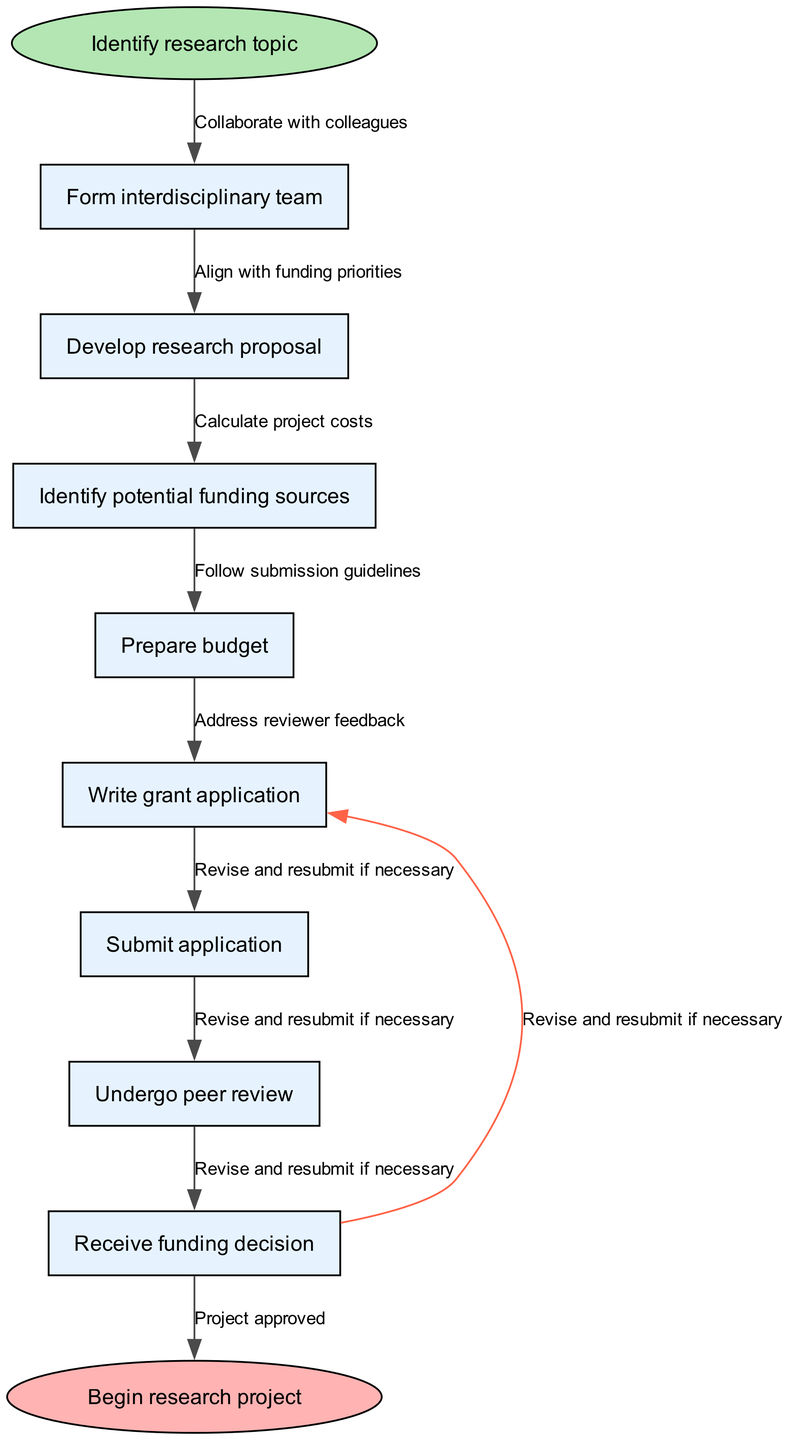What is the starting point of the process? The diagram indicates that the process starts with "Identify research topic". This is the first node connected to the starting point indicated by the ellipse shape.
Answer: Identify research topic How many nodes are in the diagram? By counting the nodes listed in the diagram, we determine that there are a total of eight nodes, which include both the start and end nodes along with the intermediate steps.
Answer: 8 What is the final step before beginning the research project? The diagram shows that the last step before starting the research project is receiving the funding decision, which is the second to last node.
Answer: Receive funding decision Which node follows "Develop research proposal"? By looking at the sequence of nodes, we see that after "Develop research proposal", the next node is "Identify potential funding sources". This order outlines the progression of the funding application process.
Answer: Identify potential funding sources What edge connects the node "Write grant application" to the subsequent node? The edge leading from "Write grant application" to the next node, which is "Submit application", is described as "Follow submission guidelines". This indicates the requirement to adhere to specific guidelines during submission.
Answer: Follow submission guidelines How many edges are present in the diagram? By counting the connections between the nodes, we can see that there are a total of seven edges in the diagram, which represent the relationships between the steps in the process.
Answer: 7 Which node can return to "Write grant application" if revisions are needed? The diagram indicates that the node labeled "Receive funding decision" has a feedback loop back to "Write grant application" with the edge labeled "Revise and resubmit if necessary". This shows the possibility of going back for revisions based on the peer review feedback.
Answer: Write grant application What is the final status indicated in the diagram? At the end of the flow chart, the status is represented as "Begin research project", which describes the outcome once the funding process has been successfully completed.
Answer: Begin research project 